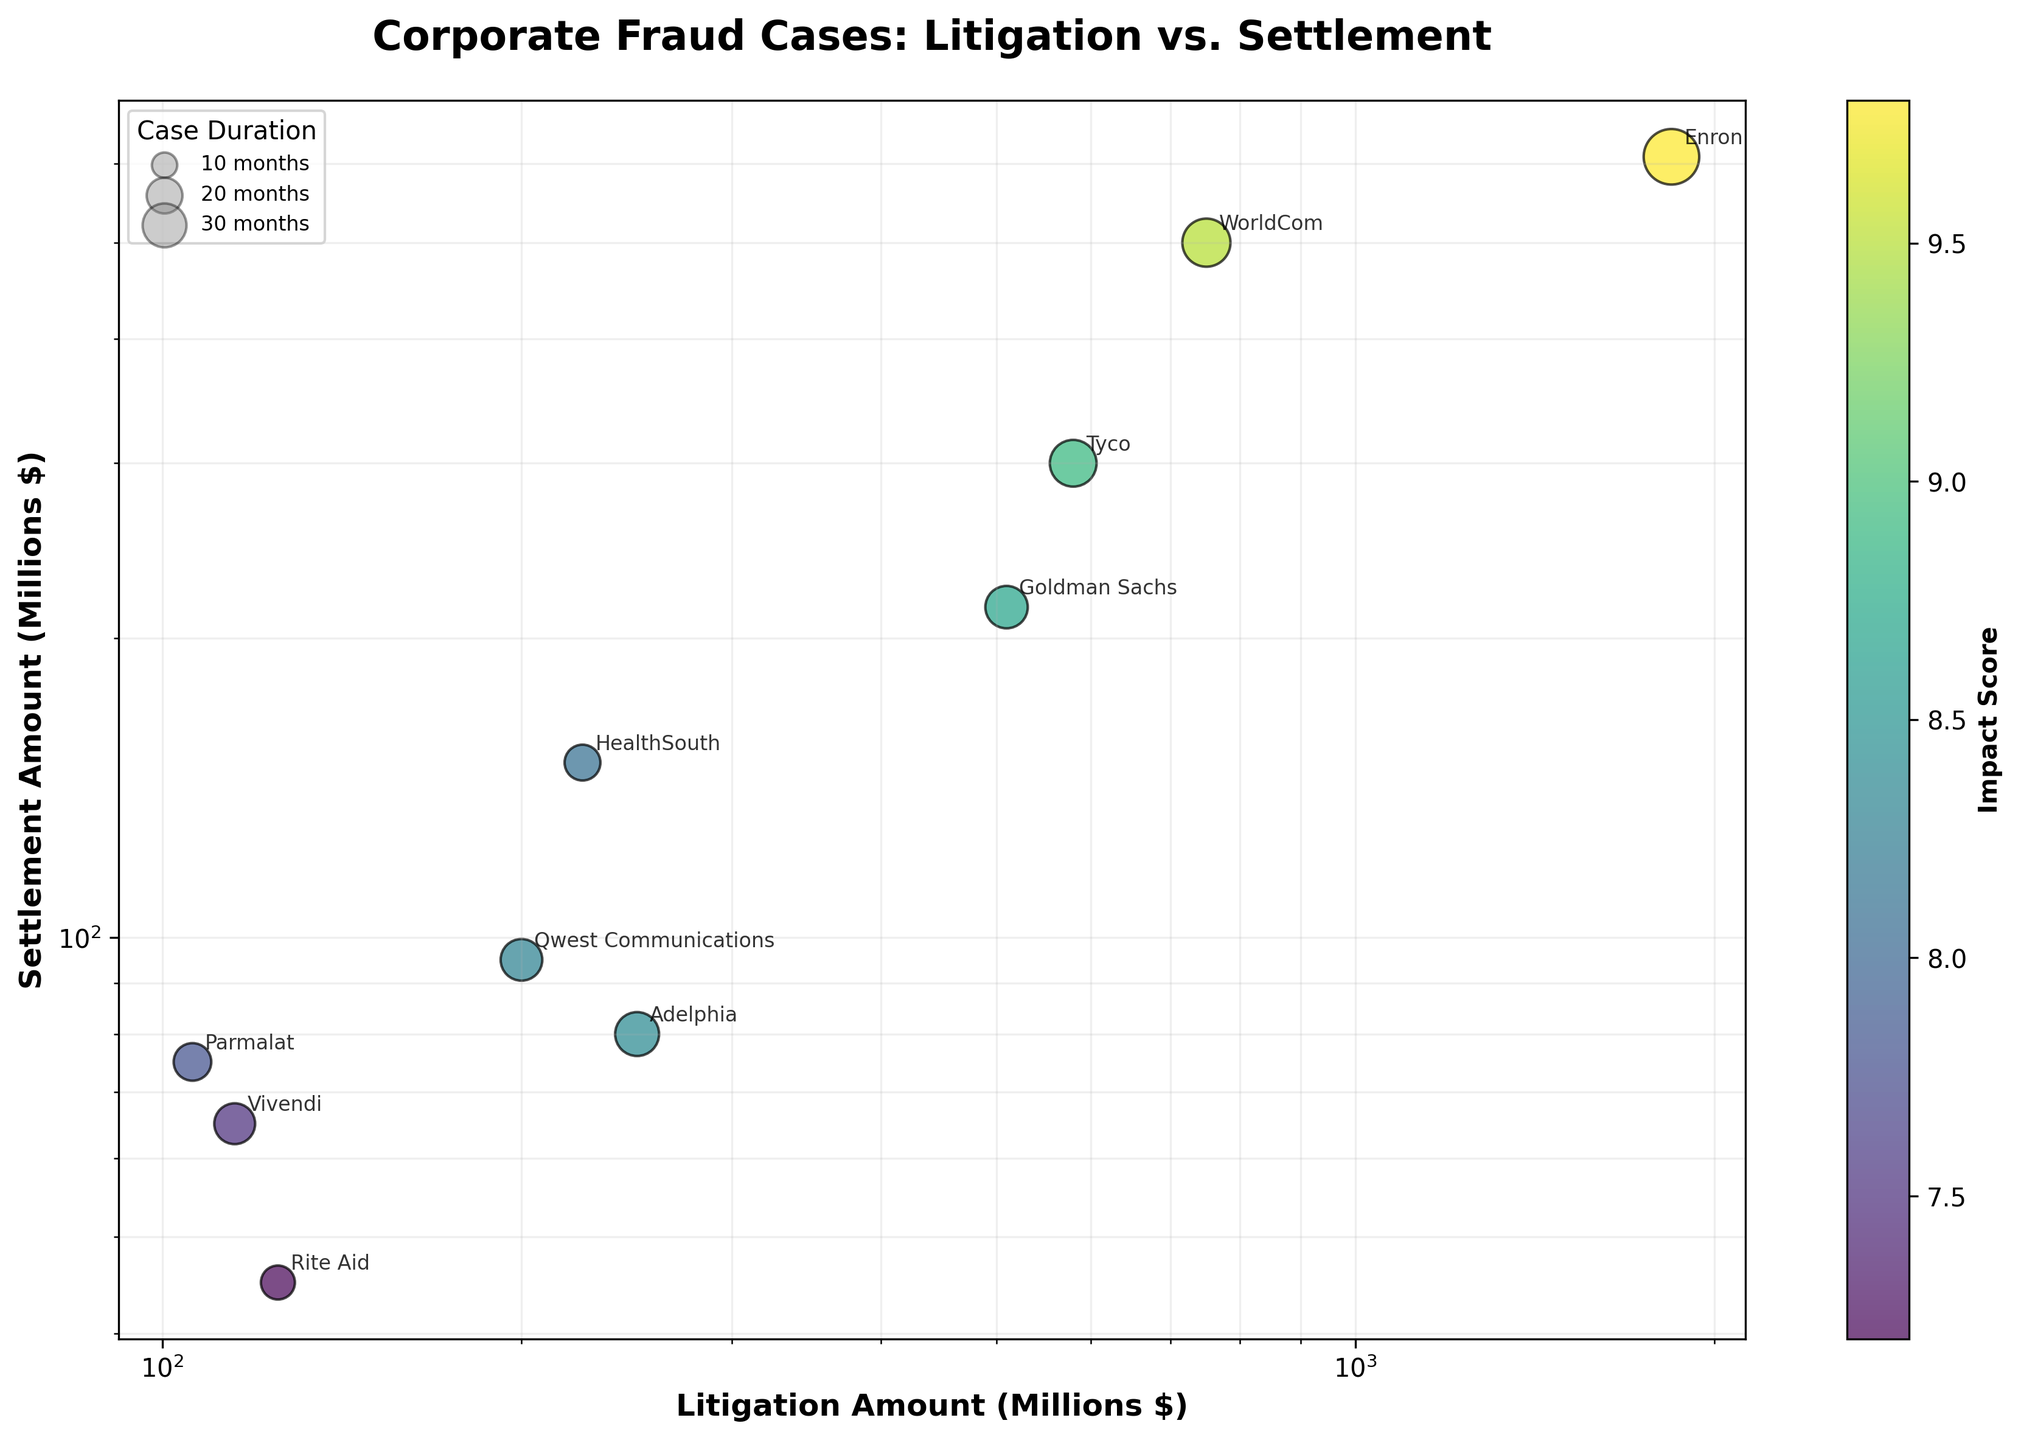What is the title of the chart? The title is located at the top of the chart, often in larger, bold font to make it easily noticeable.
Answer: Corporate Fraud Cases: Litigation vs. Settlement How many cases have both litigation and settlement amounts higher than 500 million dollars? By observing the points on the chart, you can count the number of cases in both the x-axis (Litigation Amount) and the y-axis (Settlement Amount) that are above 500 million dollars.
Answer: 3 Which case has the highest litigation amount? Review the x-axis and identify the point farthest to the right. Annotated labels can help confirm.
Answer: United States v. Enron Which case has the longest duration, and how is it represented on the chart? Larger bubble size represents longer case duration. Identify the largest bubble and check its corresponding label.
Answer: United States v. Enron, 48 months What is the overall trend between litigation and settlement amounts? By observing the scatter plot, determine if there is a general upward, downward, or no clear trend between x (Litigation Amount) and y (Settlement Amount).
Answer: Upward trend What is the average impact score of cases with litigation amounts above 700 million dollars? Identify cases above 700 million on the x-axis, sum their impact scores, and divide by the number of such cases.
Answer: (9.8 + 9.5) / 2 = 9.65 Which case has the lowest settlement amount? Review the y-axis and find the point closest to the bottom with its corresponding label.
Answer: United States v. Rite Aid Compare the litigation amounts of the cases 'United States v. Goldman Sachs' and 'SEC v. Qwest Communications'. Which is higher? Locate both cases on the chart and compare their x-axis (Litigation Amount) positions.
Answer: United States v. Qwest Communications Is there a case with an impact score below 7.5? If yes, name it. Check the color bar legend and locate any bubble with a color corresponding to an impact score below 7.5.
Answer: No What is the median case duration? List all case durations, order them, and find the middle value or average of the two middle values if even number of cases.
Answer: 26 months 